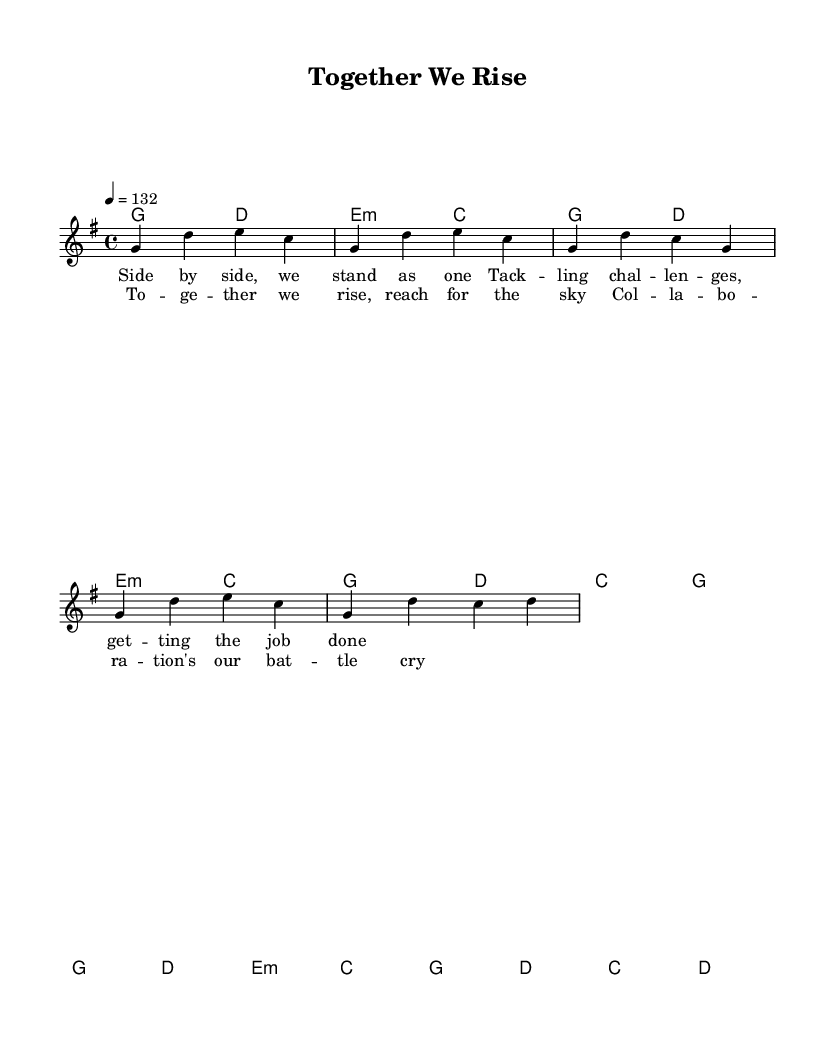What is the key signature of this music? The key signature is G major, which has one sharp (F#). You can determine this by looking at the key signature indicated at the beginning of the score, which shows one sharp.
Answer: G major What is the time signature of this music? The time signature is 4/4, which means there are four beats in each measure and a quarter note gets one beat. This is specified at the start of the piece.
Answer: 4/4 What is the tempo marking for this piece? The tempo marking is 132 beats per minute, indicated in the score with '4 = 132.' This shows the specific tempo to be played.
Answer: 132 How many measures are in the verse section? The verse section consists of four measures as can be seen by the grouping of notes, and counting from the beginning of the verse to the end.
Answer: Four measures What is the main theme of the chorus? The chorus emphasizes themes of collaboration and unity, expressed through the lyrics "Together we rise, reach for the sky." This is derived from the lyrics as well as the overall tone of the music.
Answer: Collaboration and unity Which musical element is predominant in this country rock piece? The predominant element in this country rock track is the upbeat rhythm and strong harmony, characterized by the use of major chords like G, D, and C throughout the piece. This can be identified by the chord progression and the lively tempo.
Answer: Upbeat rhythm and strong harmony What lyrical message does the song convey? The lyrical message conveys a sense of teamwork and overcoming challenges together, as highlighted in the lyrics that mention standing as one and tackling challenges.
Answer: Teamwork and overcoming challenges 